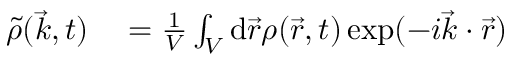<formula> <loc_0><loc_0><loc_500><loc_500>\begin{array} { r l } { \tilde { \rho } ( \vec { k } , t ) } & = \frac { 1 } { V } \int _ { V } d \vec { r } \rho ( \vec { r } , t ) \exp ( - i \vec { k } \cdot \vec { r } ) } \end{array}</formula> 